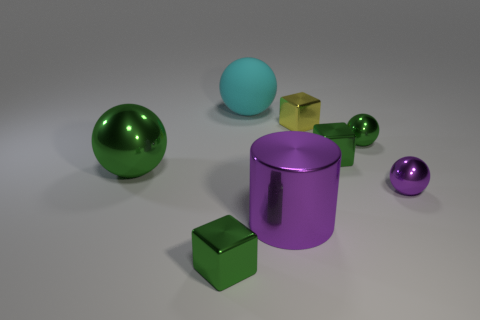Are there any other things that are the same material as the big cyan ball?
Your answer should be very brief. No. There is a large metallic cylinder; is its color the same as the small thing that is on the right side of the tiny green sphere?
Provide a succinct answer. Yes. The large metal thing in front of the large shiny sphere has what shape?
Provide a succinct answer. Cylinder. How many other objects are there of the same material as the tiny purple sphere?
Make the answer very short. 6. What is the tiny purple thing made of?
Provide a succinct answer. Metal. How many small objects are red rubber balls or cyan spheres?
Make the answer very short. 0. There is a yellow shiny object; what number of green shiny objects are to the right of it?
Your answer should be compact. 2. Are there any things that have the same color as the cylinder?
Your response must be concise. Yes. There is a yellow metallic thing that is the same size as the purple ball; what is its shape?
Make the answer very short. Cube. What number of green objects are either tiny blocks or rubber things?
Your response must be concise. 2. 